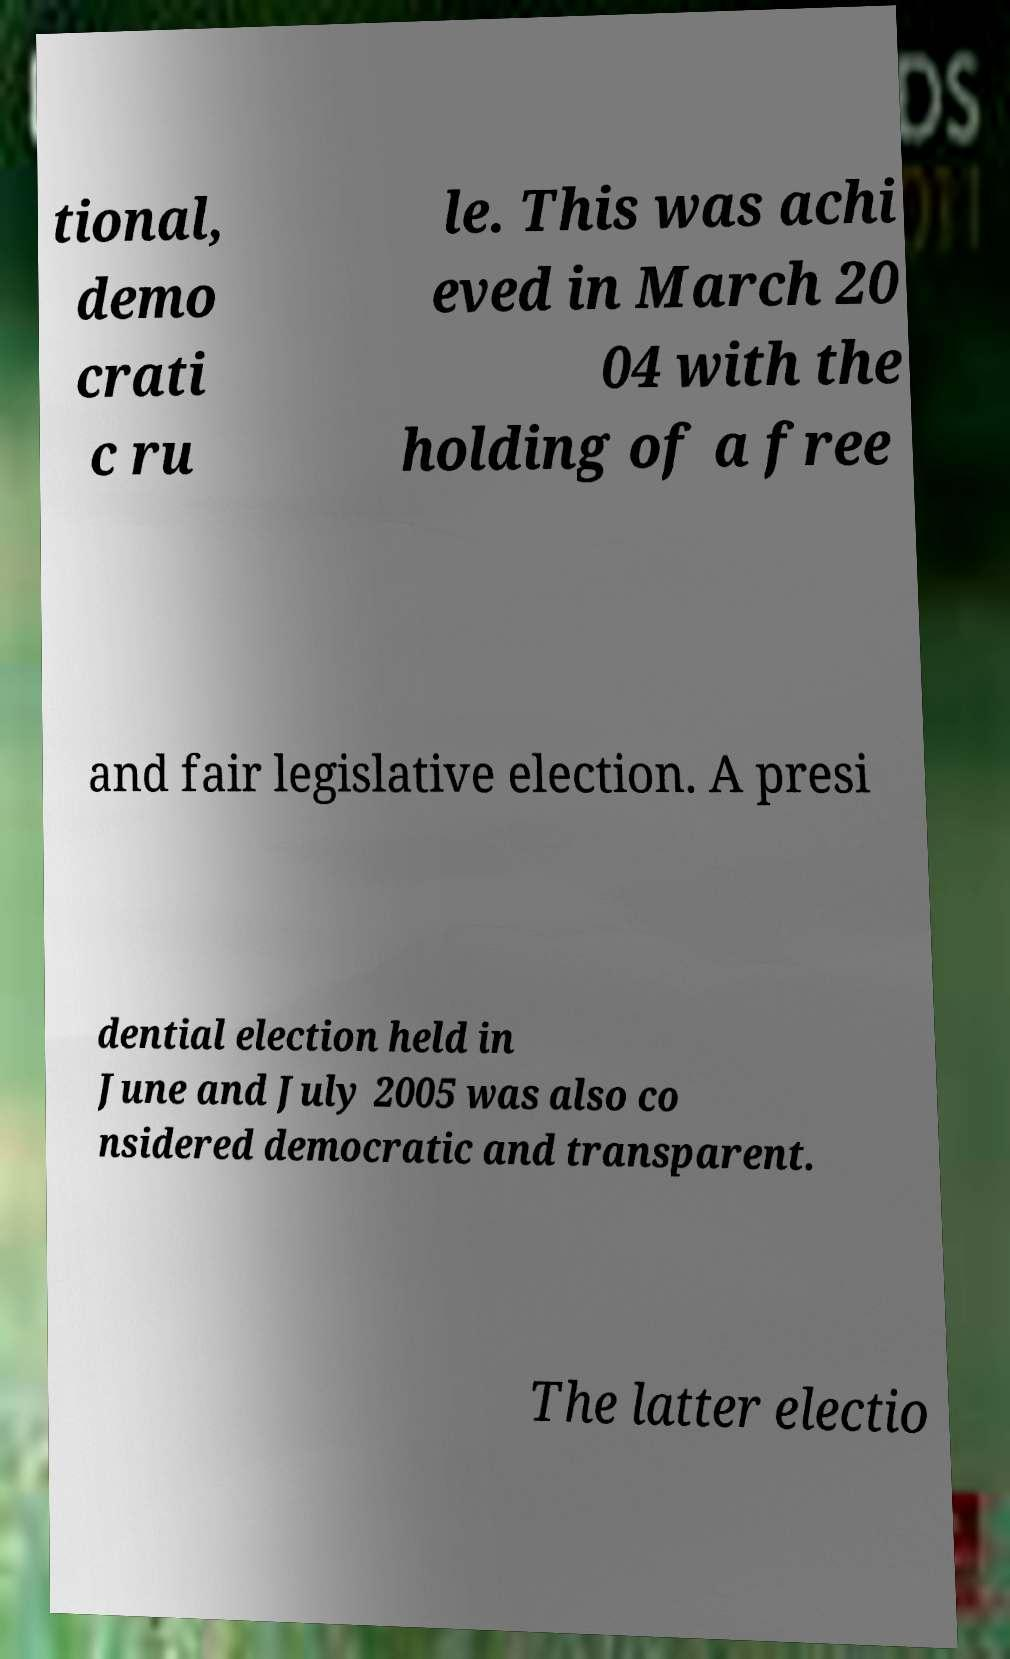Can you accurately transcribe the text from the provided image for me? tional, demo crati c ru le. This was achi eved in March 20 04 with the holding of a free and fair legislative election. A presi dential election held in June and July 2005 was also co nsidered democratic and transparent. The latter electio 